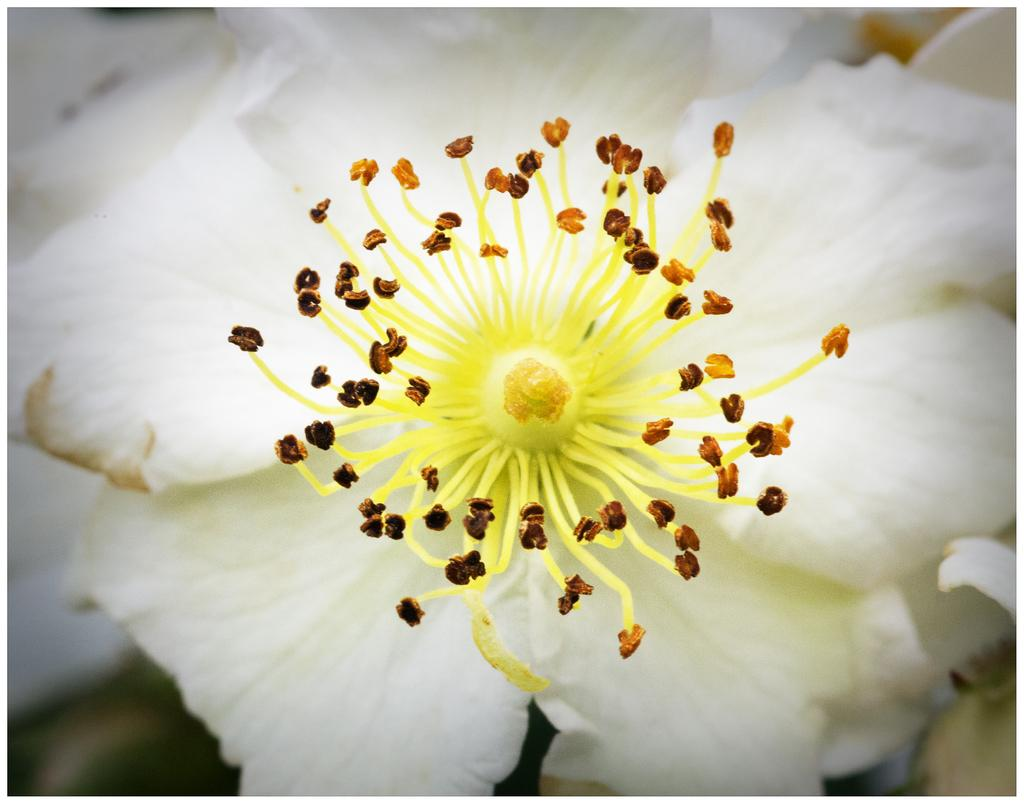What is present in the image? There is a flower in the image. Can you describe the color of the flower? The flower is white in color. How does the flower draw attention to itself in the image? The flower does not draw attention to itself in the image; it is simply a flower in the image. 